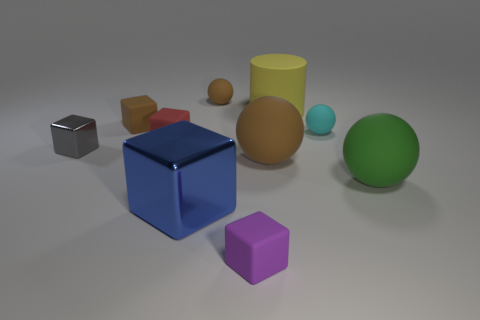What shapes can you see in the image? In the image, you can see multiple shapes including a blue cube, a purple cube, two spheres (one green, one blue), a yellow cylinder, and a brown cuboid. 